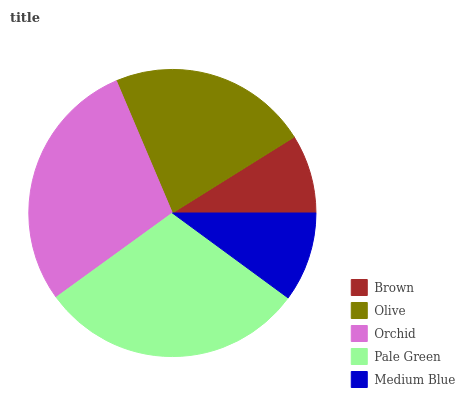Is Brown the minimum?
Answer yes or no. Yes. Is Pale Green the maximum?
Answer yes or no. Yes. Is Olive the minimum?
Answer yes or no. No. Is Olive the maximum?
Answer yes or no. No. Is Olive greater than Brown?
Answer yes or no. Yes. Is Brown less than Olive?
Answer yes or no. Yes. Is Brown greater than Olive?
Answer yes or no. No. Is Olive less than Brown?
Answer yes or no. No. Is Olive the high median?
Answer yes or no. Yes. Is Olive the low median?
Answer yes or no. Yes. Is Orchid the high median?
Answer yes or no. No. Is Orchid the low median?
Answer yes or no. No. 